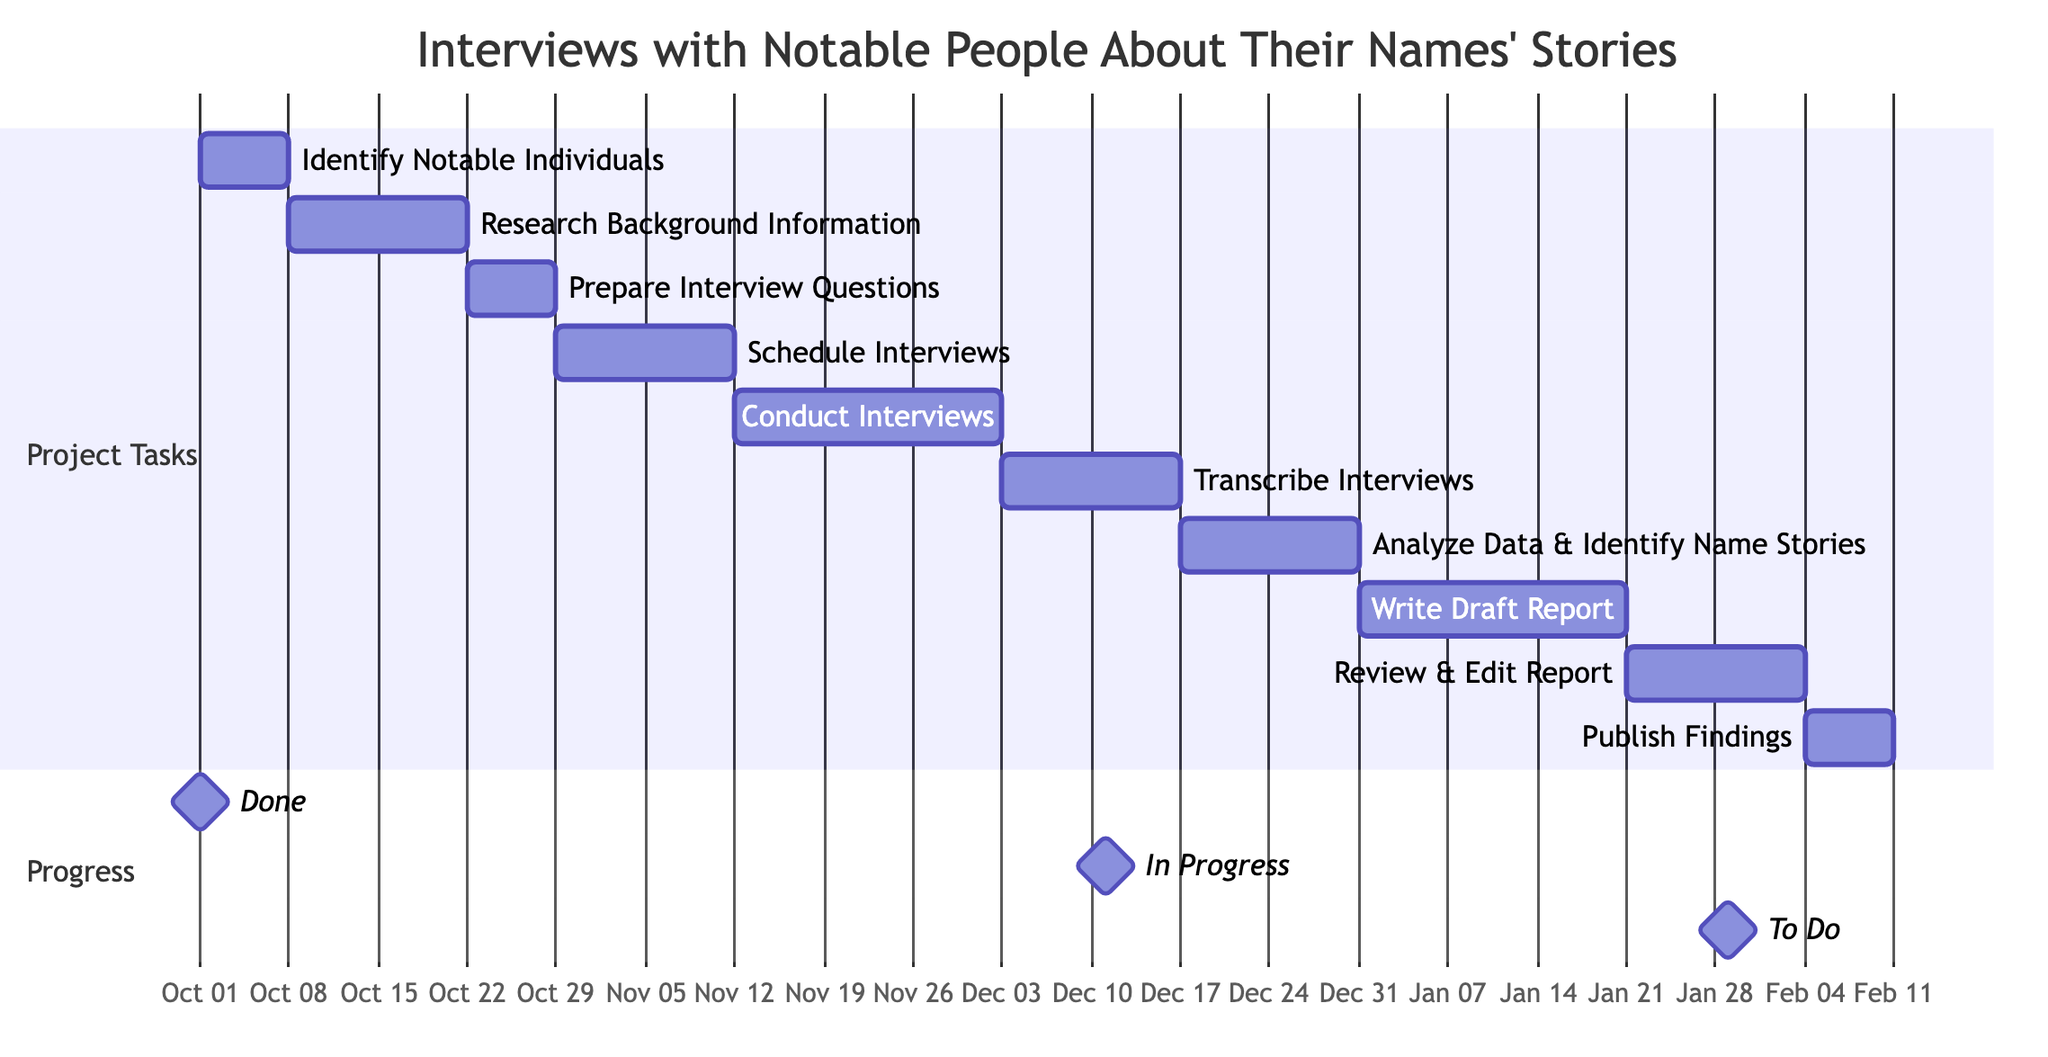What is the duration of the "Conduct Interviews" task? The "Conduct Interviews" task is represented in the diagram, showing its duration next to the task name. It indicates a duration of 3 weeks.
Answer: 3 weeks Which task starts on October 16, 2023? By examining the start dates of the tasks, we see that "Prepare Interview Questions" is listed to start on October 16, 2023.
Answer: Prepare Interview Questions How many tasks are scheduled to take place after "Analyze Data & Identify Name Stories"? Viewing the diagram, we can count the number of tasks that depend on "Analyze Data & Identify Name Stories." In this case, there is one subsequent task, which is "Write Draft Report."
Answer: 1 What is the total duration of the project? To determine the total duration of the project, we look at the timeline from the start of the first task on October 1, 2023, to the end of the last task, which ends on February 5, 2024. This covers a period of 18 weeks.
Answer: 18 weeks Which task has the longest duration? By comparing the durations of all tasks, the longest duration is seen next to "Conduct Interviews," which indicates a duration of 3 weeks.
Answer: Conduct Interviews When does the "Review & Edit Report" task start? The diagram indicates that the "Review & Edit Report" task begins after the completion of the "Write Draft Report" task, which starts on January 15, 2024. Thus, it starts on that date.
Answer: January 15, 2024 Are there any tasks that start in the same week? A closer look reveals that "Research Background Information" and "Prepare Interview Questions" start in the same week. "Research Background Information" starts on October 2, 2023, and "Prepare Interview Questions" starts on October 16, 2023, which is a week later. This implies that no two tasks start in the exact same week.
Answer: No What are the dependencies for the "Transcribe Interviews"? The diagram shows that "Transcribe Interviews" is dependent on the completion of "Conduct Interviews," meaning that the latter must be finished before starting the transcription.
Answer: Conduct Interviews How many weeks is the gap between "Schedule Interviews" and "Conduct Interviews"? By looking at the start date for "Schedule Interviews" on October 23, 2023, and the start date of "Conduct Interviews" on November 6, 2023, we can see that there is a gap of 2 weeks.
Answer: 2 weeks 